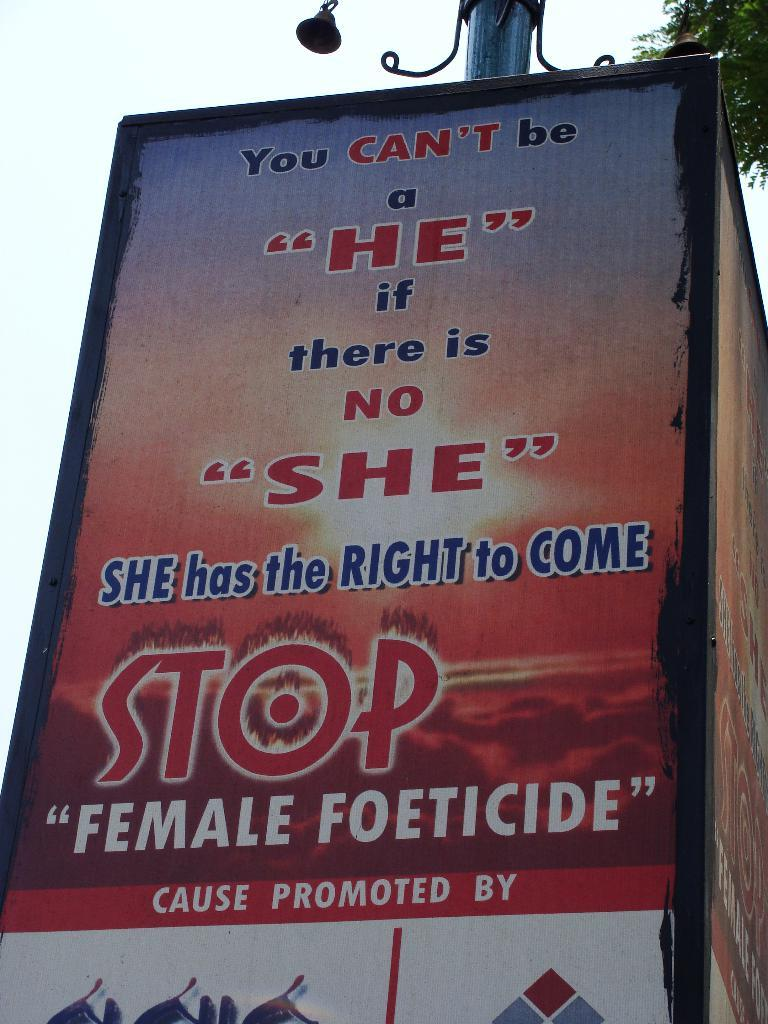What is the main subject in the center of the image? There is a poster in the center of the image. What can be found on the poster? The poster contains text. What is attached to the top of the poster? There is a pole at the top of the poster. What can be seen in the background of the image? There is a tree in the background of the image. What type of reward is being offered on the poster in the image? There is no mention of a reward on the poster in the image; it only contains text. How many pages does the poster in the image have? The poster in the image is a single, flat surface and does not have multiple pages. 